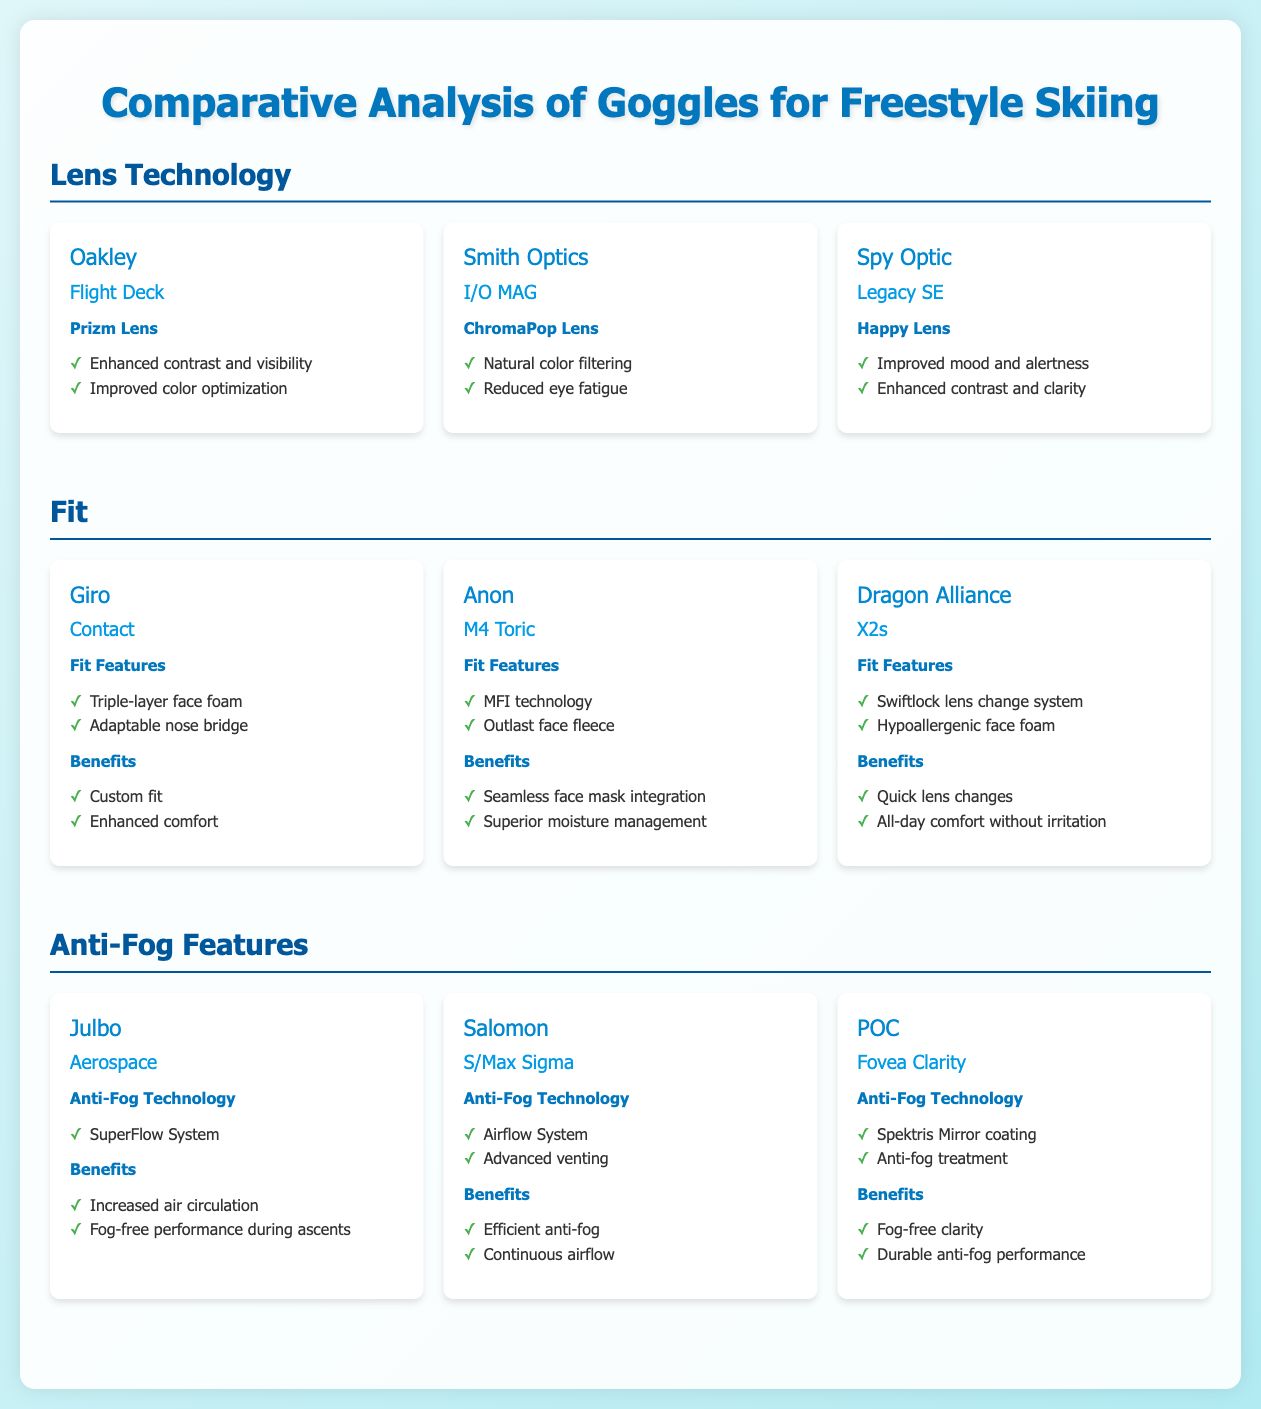What is the lens technology used in Oakley goggles? The lens technology used in Oakley goggles is Prizm Lens, as stated in the document.
Answer: Prizm Lens Which brand features the ChromaPop lens technology? The brand that features the ChromaPop lens technology is Smith Optics, as mentioned in the comparison.
Answer: Smith Optics What anti-fog technology does Julbo Aerospace utilize? Julbo Aerospace utilizes SuperFlow System for anti-fog technology, which is indicated in the infographic.
Answer: SuperFlow System What is a benefit of the Spy Optic Legacy SE goggles? A benefit of the Spy Optic Legacy SE goggles is improved mood and alertness, noted in the document.
Answer: Improved mood and alertness Which goggle model is equipped with MFI technology? The goggle model equipped with MFI technology is Anon M4 Toric, as specified in the comparison section.
Answer: Anon M4 Toric How many brands are listed under the Fit category? There are three brands listed under the Fit category in the document, which can be counted from the comparison section.
Answer: Three Which goggle model offers fog-free clarity? The goggle model that offers fog-free clarity is POC Fovea Clarity, as stated in the document.
Answer: POC Fovea Clarity What feature is common among the goggle brands in the Anti-Fog section? A common feature among the goggle brands in the Anti-Fog section is advanced venting or airflow technology, illustrating similar functionality.
Answer: Airflow technology Which brand corresponds to the "Happy Lens" technology? The brand corresponding to the "Happy Lens" technology is Spy Optic, according to the comparison.
Answer: Spy Optic 